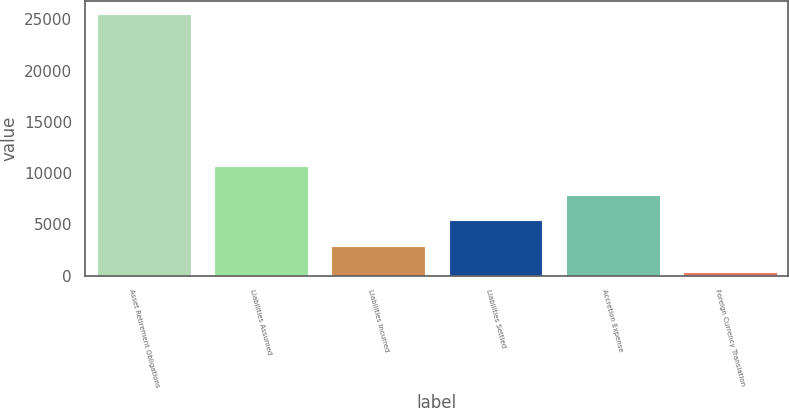Convert chart to OTSL. <chart><loc_0><loc_0><loc_500><loc_500><bar_chart><fcel>Asset Retirement Obligations<fcel>Liabilities Assumed<fcel>Liabilities Incurred<fcel>Liabilities Settled<fcel>Accretion Expense<fcel>Foreign Currency Translation<nl><fcel>25488<fcel>10678<fcel>2868.3<fcel>5381.6<fcel>7894.9<fcel>355<nl></chart> 